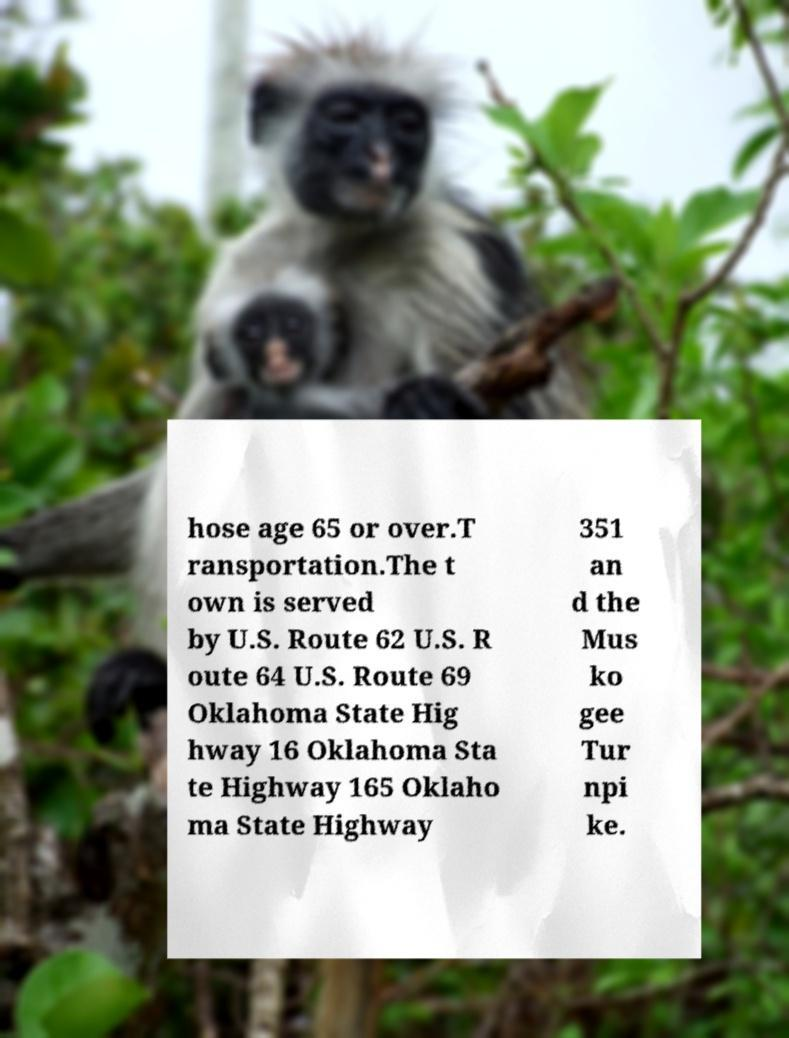What messages or text are displayed in this image? I need them in a readable, typed format. hose age 65 or over.T ransportation.The t own is served by U.S. Route 62 U.S. R oute 64 U.S. Route 69 Oklahoma State Hig hway 16 Oklahoma Sta te Highway 165 Oklaho ma State Highway 351 an d the Mus ko gee Tur npi ke. 